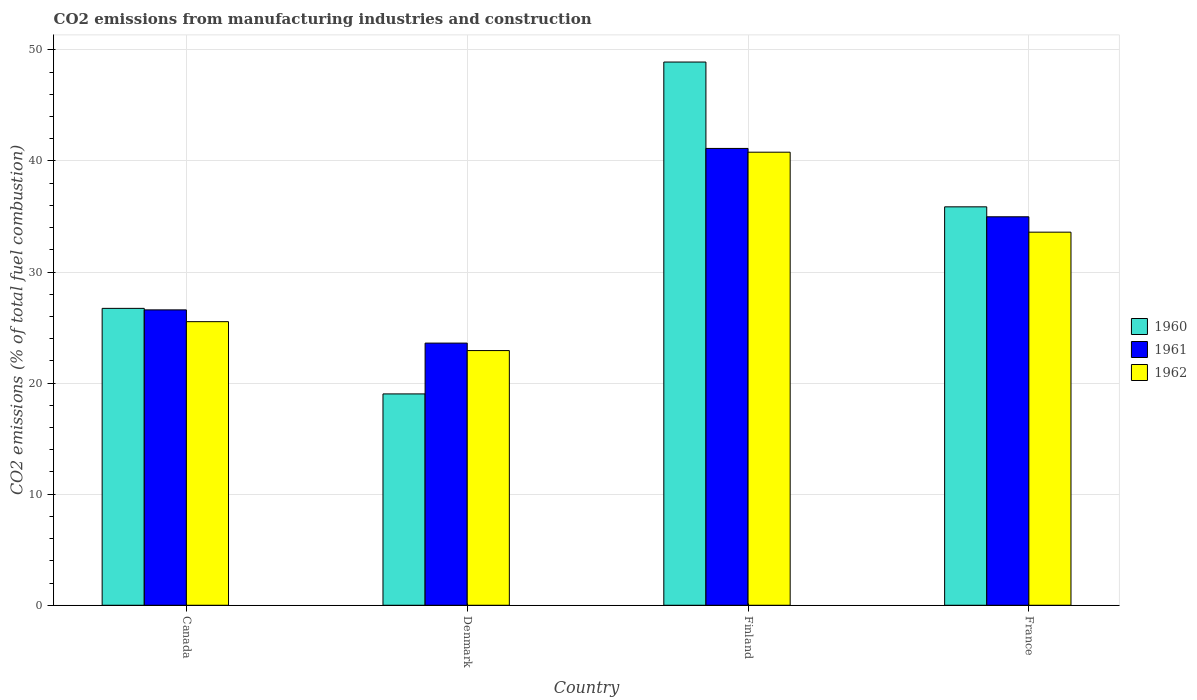How many different coloured bars are there?
Give a very brief answer. 3. Are the number of bars per tick equal to the number of legend labels?
Ensure brevity in your answer.  Yes. Are the number of bars on each tick of the X-axis equal?
Keep it short and to the point. Yes. What is the amount of CO2 emitted in 1962 in Finland?
Your answer should be very brief. 40.79. Across all countries, what is the maximum amount of CO2 emitted in 1962?
Offer a terse response. 40.79. Across all countries, what is the minimum amount of CO2 emitted in 1961?
Offer a very short reply. 23.6. In which country was the amount of CO2 emitted in 1961 maximum?
Provide a succinct answer. Finland. What is the total amount of CO2 emitted in 1960 in the graph?
Give a very brief answer. 130.54. What is the difference between the amount of CO2 emitted in 1961 in Denmark and that in France?
Keep it short and to the point. -11.37. What is the difference between the amount of CO2 emitted in 1962 in Denmark and the amount of CO2 emitted in 1960 in Finland?
Your answer should be compact. -25.98. What is the average amount of CO2 emitted in 1960 per country?
Your response must be concise. 32.64. What is the difference between the amount of CO2 emitted of/in 1960 and amount of CO2 emitted of/in 1962 in Finland?
Your response must be concise. 8.12. In how many countries, is the amount of CO2 emitted in 1962 greater than 16 %?
Keep it short and to the point. 4. What is the ratio of the amount of CO2 emitted in 1961 in Canada to that in France?
Your response must be concise. 0.76. Is the difference between the amount of CO2 emitted in 1960 in Canada and France greater than the difference between the amount of CO2 emitted in 1962 in Canada and France?
Keep it short and to the point. No. What is the difference between the highest and the second highest amount of CO2 emitted in 1960?
Provide a succinct answer. 22.18. What is the difference between the highest and the lowest amount of CO2 emitted in 1960?
Your response must be concise. 29.88. Are the values on the major ticks of Y-axis written in scientific E-notation?
Your answer should be compact. No. Does the graph contain any zero values?
Provide a succinct answer. No. Does the graph contain grids?
Give a very brief answer. Yes. How many legend labels are there?
Give a very brief answer. 3. What is the title of the graph?
Give a very brief answer. CO2 emissions from manufacturing industries and construction. Does "1972" appear as one of the legend labels in the graph?
Your answer should be very brief. No. What is the label or title of the X-axis?
Provide a short and direct response. Country. What is the label or title of the Y-axis?
Your response must be concise. CO2 emissions (% of total fuel combustion). What is the CO2 emissions (% of total fuel combustion) in 1960 in Canada?
Make the answer very short. 26.73. What is the CO2 emissions (% of total fuel combustion) of 1961 in Canada?
Your answer should be compact. 26.59. What is the CO2 emissions (% of total fuel combustion) in 1962 in Canada?
Provide a succinct answer. 25.53. What is the CO2 emissions (% of total fuel combustion) in 1960 in Denmark?
Give a very brief answer. 19.03. What is the CO2 emissions (% of total fuel combustion) in 1961 in Denmark?
Offer a terse response. 23.6. What is the CO2 emissions (% of total fuel combustion) of 1962 in Denmark?
Give a very brief answer. 22.93. What is the CO2 emissions (% of total fuel combustion) in 1960 in Finland?
Offer a very short reply. 48.91. What is the CO2 emissions (% of total fuel combustion) of 1961 in Finland?
Make the answer very short. 41.13. What is the CO2 emissions (% of total fuel combustion) of 1962 in Finland?
Your answer should be very brief. 40.79. What is the CO2 emissions (% of total fuel combustion) of 1960 in France?
Offer a very short reply. 35.87. What is the CO2 emissions (% of total fuel combustion) in 1961 in France?
Ensure brevity in your answer.  34.98. What is the CO2 emissions (% of total fuel combustion) of 1962 in France?
Your answer should be compact. 33.59. Across all countries, what is the maximum CO2 emissions (% of total fuel combustion) of 1960?
Ensure brevity in your answer.  48.91. Across all countries, what is the maximum CO2 emissions (% of total fuel combustion) in 1961?
Give a very brief answer. 41.13. Across all countries, what is the maximum CO2 emissions (% of total fuel combustion) in 1962?
Ensure brevity in your answer.  40.79. Across all countries, what is the minimum CO2 emissions (% of total fuel combustion) in 1960?
Your answer should be compact. 19.03. Across all countries, what is the minimum CO2 emissions (% of total fuel combustion) in 1961?
Provide a succinct answer. 23.6. Across all countries, what is the minimum CO2 emissions (% of total fuel combustion) in 1962?
Ensure brevity in your answer.  22.93. What is the total CO2 emissions (% of total fuel combustion) in 1960 in the graph?
Your answer should be very brief. 130.54. What is the total CO2 emissions (% of total fuel combustion) of 1961 in the graph?
Your answer should be compact. 126.3. What is the total CO2 emissions (% of total fuel combustion) of 1962 in the graph?
Offer a very short reply. 122.85. What is the difference between the CO2 emissions (% of total fuel combustion) in 1960 in Canada and that in Denmark?
Offer a terse response. 7.7. What is the difference between the CO2 emissions (% of total fuel combustion) in 1961 in Canada and that in Denmark?
Ensure brevity in your answer.  2.99. What is the difference between the CO2 emissions (% of total fuel combustion) of 1962 in Canada and that in Denmark?
Your response must be concise. 2.6. What is the difference between the CO2 emissions (% of total fuel combustion) of 1960 in Canada and that in Finland?
Provide a succinct answer. -22.18. What is the difference between the CO2 emissions (% of total fuel combustion) in 1961 in Canada and that in Finland?
Give a very brief answer. -14.54. What is the difference between the CO2 emissions (% of total fuel combustion) in 1962 in Canada and that in Finland?
Keep it short and to the point. -15.26. What is the difference between the CO2 emissions (% of total fuel combustion) in 1960 in Canada and that in France?
Offer a very short reply. -9.14. What is the difference between the CO2 emissions (% of total fuel combustion) in 1961 in Canada and that in France?
Make the answer very short. -8.38. What is the difference between the CO2 emissions (% of total fuel combustion) in 1962 in Canada and that in France?
Ensure brevity in your answer.  -8.06. What is the difference between the CO2 emissions (% of total fuel combustion) in 1960 in Denmark and that in Finland?
Ensure brevity in your answer.  -29.88. What is the difference between the CO2 emissions (% of total fuel combustion) in 1961 in Denmark and that in Finland?
Your answer should be very brief. -17.53. What is the difference between the CO2 emissions (% of total fuel combustion) in 1962 in Denmark and that in Finland?
Your answer should be compact. -17.86. What is the difference between the CO2 emissions (% of total fuel combustion) of 1960 in Denmark and that in France?
Keep it short and to the point. -16.84. What is the difference between the CO2 emissions (% of total fuel combustion) of 1961 in Denmark and that in France?
Give a very brief answer. -11.37. What is the difference between the CO2 emissions (% of total fuel combustion) in 1962 in Denmark and that in France?
Give a very brief answer. -10.66. What is the difference between the CO2 emissions (% of total fuel combustion) of 1960 in Finland and that in France?
Offer a terse response. 13.04. What is the difference between the CO2 emissions (% of total fuel combustion) of 1961 in Finland and that in France?
Your answer should be very brief. 6.16. What is the difference between the CO2 emissions (% of total fuel combustion) in 1962 in Finland and that in France?
Offer a very short reply. 7.2. What is the difference between the CO2 emissions (% of total fuel combustion) in 1960 in Canada and the CO2 emissions (% of total fuel combustion) in 1961 in Denmark?
Ensure brevity in your answer.  3.13. What is the difference between the CO2 emissions (% of total fuel combustion) of 1960 in Canada and the CO2 emissions (% of total fuel combustion) of 1962 in Denmark?
Your response must be concise. 3.8. What is the difference between the CO2 emissions (% of total fuel combustion) in 1961 in Canada and the CO2 emissions (% of total fuel combustion) in 1962 in Denmark?
Provide a short and direct response. 3.66. What is the difference between the CO2 emissions (% of total fuel combustion) of 1960 in Canada and the CO2 emissions (% of total fuel combustion) of 1961 in Finland?
Your response must be concise. -14.4. What is the difference between the CO2 emissions (% of total fuel combustion) of 1960 in Canada and the CO2 emissions (% of total fuel combustion) of 1962 in Finland?
Keep it short and to the point. -14.06. What is the difference between the CO2 emissions (% of total fuel combustion) in 1961 in Canada and the CO2 emissions (% of total fuel combustion) in 1962 in Finland?
Provide a succinct answer. -14.2. What is the difference between the CO2 emissions (% of total fuel combustion) of 1960 in Canada and the CO2 emissions (% of total fuel combustion) of 1961 in France?
Offer a very short reply. -8.24. What is the difference between the CO2 emissions (% of total fuel combustion) of 1960 in Canada and the CO2 emissions (% of total fuel combustion) of 1962 in France?
Your answer should be very brief. -6.86. What is the difference between the CO2 emissions (% of total fuel combustion) in 1961 in Canada and the CO2 emissions (% of total fuel combustion) in 1962 in France?
Offer a terse response. -7. What is the difference between the CO2 emissions (% of total fuel combustion) of 1960 in Denmark and the CO2 emissions (% of total fuel combustion) of 1961 in Finland?
Your response must be concise. -22.1. What is the difference between the CO2 emissions (% of total fuel combustion) of 1960 in Denmark and the CO2 emissions (% of total fuel combustion) of 1962 in Finland?
Offer a very short reply. -21.76. What is the difference between the CO2 emissions (% of total fuel combustion) in 1961 in Denmark and the CO2 emissions (% of total fuel combustion) in 1962 in Finland?
Keep it short and to the point. -17.19. What is the difference between the CO2 emissions (% of total fuel combustion) in 1960 in Denmark and the CO2 emissions (% of total fuel combustion) in 1961 in France?
Provide a succinct answer. -15.95. What is the difference between the CO2 emissions (% of total fuel combustion) in 1960 in Denmark and the CO2 emissions (% of total fuel combustion) in 1962 in France?
Give a very brief answer. -14.56. What is the difference between the CO2 emissions (% of total fuel combustion) in 1961 in Denmark and the CO2 emissions (% of total fuel combustion) in 1962 in France?
Make the answer very short. -9.99. What is the difference between the CO2 emissions (% of total fuel combustion) in 1960 in Finland and the CO2 emissions (% of total fuel combustion) in 1961 in France?
Keep it short and to the point. 13.93. What is the difference between the CO2 emissions (% of total fuel combustion) of 1960 in Finland and the CO2 emissions (% of total fuel combustion) of 1962 in France?
Your response must be concise. 15.32. What is the difference between the CO2 emissions (% of total fuel combustion) in 1961 in Finland and the CO2 emissions (% of total fuel combustion) in 1962 in France?
Keep it short and to the point. 7.54. What is the average CO2 emissions (% of total fuel combustion) of 1960 per country?
Your answer should be compact. 32.64. What is the average CO2 emissions (% of total fuel combustion) of 1961 per country?
Provide a short and direct response. 31.58. What is the average CO2 emissions (% of total fuel combustion) in 1962 per country?
Offer a terse response. 30.71. What is the difference between the CO2 emissions (% of total fuel combustion) in 1960 and CO2 emissions (% of total fuel combustion) in 1961 in Canada?
Give a very brief answer. 0.14. What is the difference between the CO2 emissions (% of total fuel combustion) of 1960 and CO2 emissions (% of total fuel combustion) of 1962 in Canada?
Your response must be concise. 1.2. What is the difference between the CO2 emissions (% of total fuel combustion) in 1961 and CO2 emissions (% of total fuel combustion) in 1962 in Canada?
Ensure brevity in your answer.  1.06. What is the difference between the CO2 emissions (% of total fuel combustion) in 1960 and CO2 emissions (% of total fuel combustion) in 1961 in Denmark?
Your response must be concise. -4.57. What is the difference between the CO2 emissions (% of total fuel combustion) in 1960 and CO2 emissions (% of total fuel combustion) in 1962 in Denmark?
Make the answer very short. -3.9. What is the difference between the CO2 emissions (% of total fuel combustion) of 1961 and CO2 emissions (% of total fuel combustion) of 1962 in Denmark?
Your response must be concise. 0.67. What is the difference between the CO2 emissions (% of total fuel combustion) of 1960 and CO2 emissions (% of total fuel combustion) of 1961 in Finland?
Your answer should be compact. 7.78. What is the difference between the CO2 emissions (% of total fuel combustion) in 1960 and CO2 emissions (% of total fuel combustion) in 1962 in Finland?
Offer a terse response. 8.12. What is the difference between the CO2 emissions (% of total fuel combustion) of 1961 and CO2 emissions (% of total fuel combustion) of 1962 in Finland?
Your answer should be compact. 0.34. What is the difference between the CO2 emissions (% of total fuel combustion) of 1960 and CO2 emissions (% of total fuel combustion) of 1961 in France?
Keep it short and to the point. 0.9. What is the difference between the CO2 emissions (% of total fuel combustion) of 1960 and CO2 emissions (% of total fuel combustion) of 1962 in France?
Give a very brief answer. 2.28. What is the difference between the CO2 emissions (% of total fuel combustion) of 1961 and CO2 emissions (% of total fuel combustion) of 1962 in France?
Give a very brief answer. 1.38. What is the ratio of the CO2 emissions (% of total fuel combustion) of 1960 in Canada to that in Denmark?
Your answer should be compact. 1.4. What is the ratio of the CO2 emissions (% of total fuel combustion) in 1961 in Canada to that in Denmark?
Your answer should be very brief. 1.13. What is the ratio of the CO2 emissions (% of total fuel combustion) in 1962 in Canada to that in Denmark?
Keep it short and to the point. 1.11. What is the ratio of the CO2 emissions (% of total fuel combustion) in 1960 in Canada to that in Finland?
Provide a short and direct response. 0.55. What is the ratio of the CO2 emissions (% of total fuel combustion) in 1961 in Canada to that in Finland?
Offer a very short reply. 0.65. What is the ratio of the CO2 emissions (% of total fuel combustion) of 1962 in Canada to that in Finland?
Keep it short and to the point. 0.63. What is the ratio of the CO2 emissions (% of total fuel combustion) of 1960 in Canada to that in France?
Offer a very short reply. 0.75. What is the ratio of the CO2 emissions (% of total fuel combustion) in 1961 in Canada to that in France?
Ensure brevity in your answer.  0.76. What is the ratio of the CO2 emissions (% of total fuel combustion) in 1962 in Canada to that in France?
Your answer should be compact. 0.76. What is the ratio of the CO2 emissions (% of total fuel combustion) in 1960 in Denmark to that in Finland?
Your answer should be compact. 0.39. What is the ratio of the CO2 emissions (% of total fuel combustion) in 1961 in Denmark to that in Finland?
Offer a terse response. 0.57. What is the ratio of the CO2 emissions (% of total fuel combustion) of 1962 in Denmark to that in Finland?
Provide a succinct answer. 0.56. What is the ratio of the CO2 emissions (% of total fuel combustion) of 1960 in Denmark to that in France?
Provide a short and direct response. 0.53. What is the ratio of the CO2 emissions (% of total fuel combustion) in 1961 in Denmark to that in France?
Ensure brevity in your answer.  0.67. What is the ratio of the CO2 emissions (% of total fuel combustion) of 1962 in Denmark to that in France?
Offer a very short reply. 0.68. What is the ratio of the CO2 emissions (% of total fuel combustion) of 1960 in Finland to that in France?
Your answer should be very brief. 1.36. What is the ratio of the CO2 emissions (% of total fuel combustion) of 1961 in Finland to that in France?
Give a very brief answer. 1.18. What is the ratio of the CO2 emissions (% of total fuel combustion) of 1962 in Finland to that in France?
Your answer should be compact. 1.21. What is the difference between the highest and the second highest CO2 emissions (% of total fuel combustion) of 1960?
Provide a short and direct response. 13.04. What is the difference between the highest and the second highest CO2 emissions (% of total fuel combustion) in 1961?
Give a very brief answer. 6.16. What is the difference between the highest and the second highest CO2 emissions (% of total fuel combustion) in 1962?
Provide a short and direct response. 7.2. What is the difference between the highest and the lowest CO2 emissions (% of total fuel combustion) of 1960?
Provide a succinct answer. 29.88. What is the difference between the highest and the lowest CO2 emissions (% of total fuel combustion) in 1961?
Offer a terse response. 17.53. What is the difference between the highest and the lowest CO2 emissions (% of total fuel combustion) in 1962?
Give a very brief answer. 17.86. 